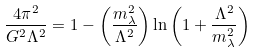<formula> <loc_0><loc_0><loc_500><loc_500>\frac { 4 \pi ^ { 2 } } { G ^ { 2 } \Lambda ^ { 2 } } = 1 - \left ( \frac { m _ { \lambda } ^ { 2 } } { \Lambda ^ { 2 } } \right ) \ln \left ( 1 + \frac { \Lambda ^ { 2 } } { m _ { \lambda } ^ { 2 } } \right )</formula> 